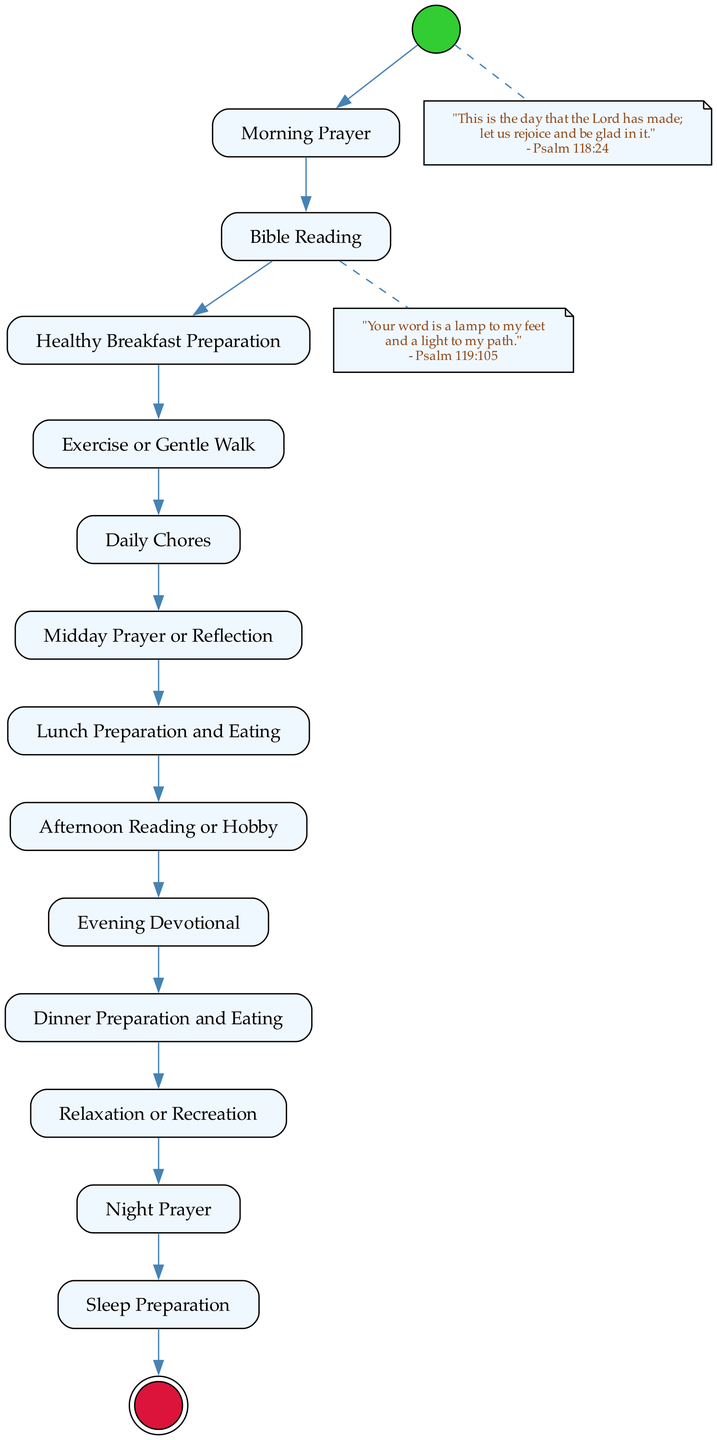What is the starting action of the day? The day begins with the "Start of Day," which is the initial node indicating the beginning of the routine.
Answer: Start of Day How many action nodes are in the diagram? By counting the action nodes listed, we find there are twelve distinct action nodes.
Answer: Twelve What follows "Morning Prayer"? In the sequence of the routine, directly after "Morning Prayer," the next action is "Bible Reading." This is evident from the flow of actions in the diagram.
Answer: Bible Reading Which activity is depicted before "Evening Devotional"? The activity that comes just before "Evening Devotional" is "Dinner Preparation and Eating," as seen by tracing the flow of actions leading up to it.
Answer: Dinner Preparation and Eating Where is the quote from Psalm 118:24 placed in the diagram? The quote from Psalm 118:24 is placed after the "Start of Day" node and is shown as a note connected by a dashed line to indicate its relation to the start of the day.
Answer: After Start of Day What activity is last before reaching the "End of Day"? The final action before concluding with "End of Day" is "Night Prayer," which provides closure to this daily routine.
Answer: Night Prayer How many prayers are included in this daily routine? There are three specific prayer activities throughout the routine: "Morning Prayer," "Midday Prayer or Reflection," and "Night Prayer." By identifying these, we confirm the total count.
Answer: Three Which action comes after "Lunch Preparation and Eating"? The sequence indicates that directly following "Lunch Preparation and Eating" is "Afternoon Reading or Hobby." This shows the progression of the daily routine.
Answer: Afternoon Reading or Hobby What kind of node is "End of Day"? "End of Day" is categorized as an activity final node, which is represented by a double circle in the diagram, indicating the conclusion of the routine.
Answer: Activity final node 